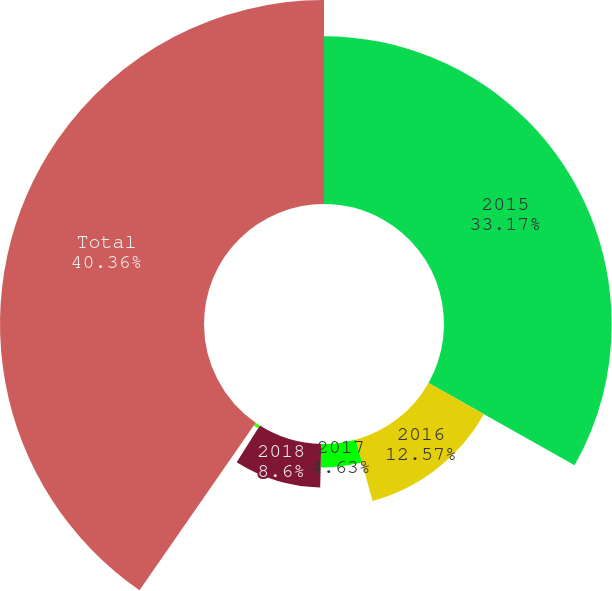Convert chart to OTSL. <chart><loc_0><loc_0><loc_500><loc_500><pie_chart><fcel>2015<fcel>2016<fcel>2017<fcel>2018<fcel>2019<fcel>Total<nl><fcel>33.17%<fcel>12.57%<fcel>4.63%<fcel>8.6%<fcel>0.67%<fcel>40.36%<nl></chart> 